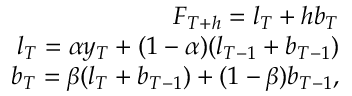<formula> <loc_0><loc_0><loc_500><loc_500>\begin{array} { r } { F _ { T + h } = l _ { T } + h b _ { T } } \\ { l _ { T } = \alpha y _ { T } + ( 1 - \alpha ) ( l _ { T - 1 } + b _ { T - 1 } ) } \\ { b _ { T } = \beta ( l _ { T } + b _ { T - 1 } ) + ( 1 - \beta ) b _ { T - 1 } , } \end{array}</formula> 